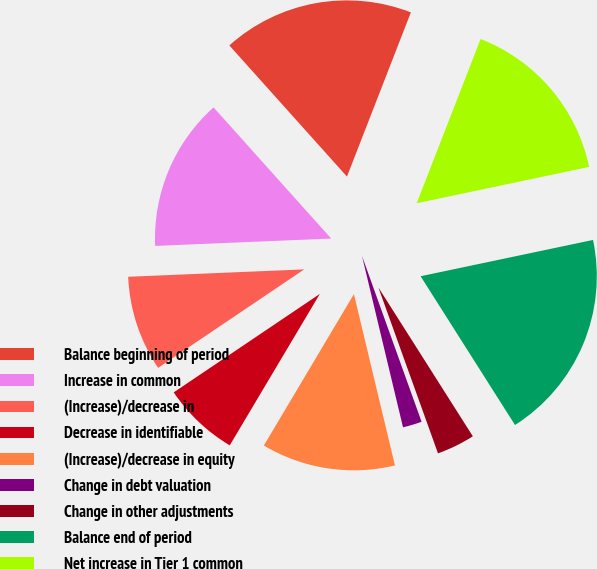Convert chart. <chart><loc_0><loc_0><loc_500><loc_500><pie_chart><fcel>Balance beginning of period<fcel>Increase in common<fcel>(Increase)/decrease in<fcel>Decrease in identifiable<fcel>(Increase)/decrease in equity<fcel>Change in debt valuation<fcel>Change in other adjustments<fcel>Balance end of period<fcel>Net increase in Tier 1 common<nl><fcel>17.54%<fcel>14.03%<fcel>8.77%<fcel>7.02%<fcel>12.28%<fcel>1.75%<fcel>3.51%<fcel>19.3%<fcel>15.79%<nl></chart> 